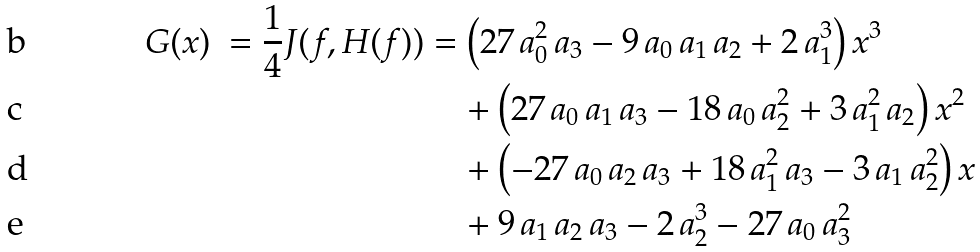<formula> <loc_0><loc_0><loc_500><loc_500>G ( x ) \ = \frac { 1 } { 4 } J ( f , H ( f ) ) & = \left ( 2 7 \, a _ { 0 } ^ { 2 } \, { a _ { 3 } } - 9 \, { a _ { 0 } } \, { a _ { 1 } } \, { a _ { 2 } } + 2 \, a _ { 1 } ^ { 3 } \right ) { x } ^ { 3 } \\ & \quad + \left ( 2 7 \, { a _ { 0 } } \, { a _ { 1 } } \, { a _ { 3 } } - 1 8 \, { a _ { 0 } } \, a _ { 2 } ^ { 2 } + 3 \, a _ { 1 } ^ { 2 } \, { a _ { 2 } } \right ) { x } ^ { 2 } \\ & \quad + \left ( - 2 7 \, { a _ { 0 } } \, { a _ { 2 } } \, { a _ { 3 } } + 1 8 \, a _ { 1 } ^ { 2 } \, { a _ { 3 } } - 3 \, { a _ { 1 } } \, a _ { 2 } ^ { 2 } \right ) x \\ & \quad + 9 \, { a _ { 1 } } \, { a _ { 2 } } \, { a _ { 3 } } - 2 \, a _ { 2 } ^ { 3 } - 2 7 \, { a _ { 0 } } \, a _ { 3 } ^ { 2 }</formula> 